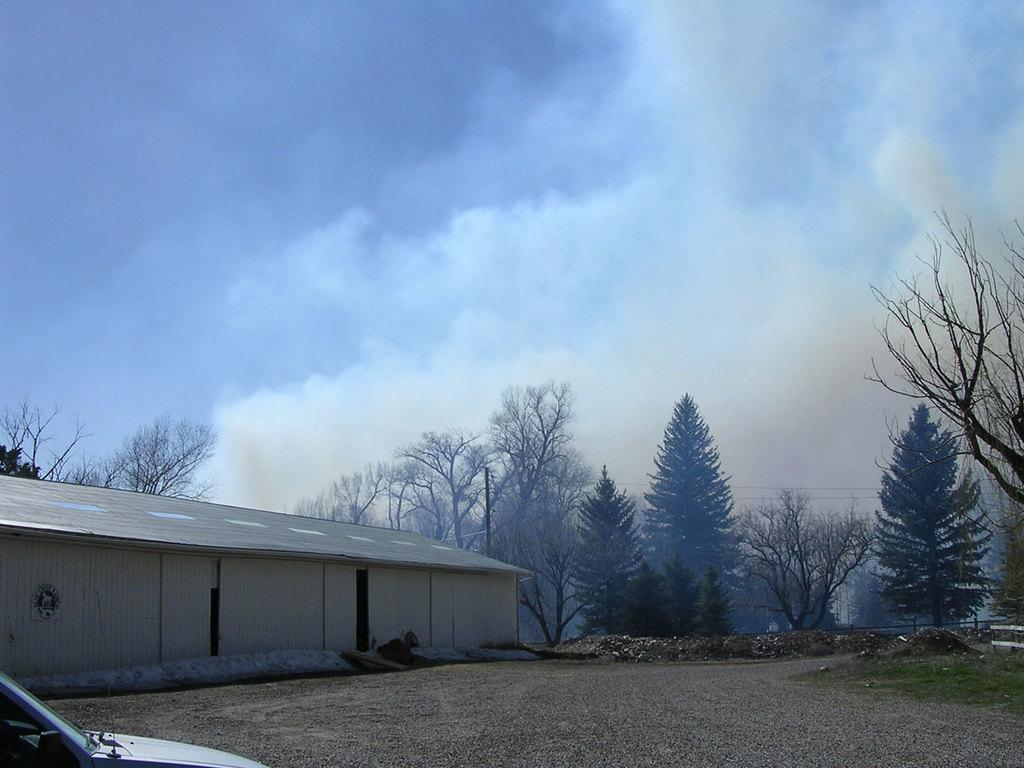What is on the ground in the image? There is a car on the ground in the image. What structure can be seen at the side of the image? There is a building at the side of the image. What type of vegetation is present in the image? There are trees in the image. What type of barrier is visible in the image? There is a fence in the image. What is visible above the ground in the image? The sky is visible in the image. Where is the camera located in the image? There is no camera present in the image. Can you describe the yard in the image? There is no yard present in the image. 